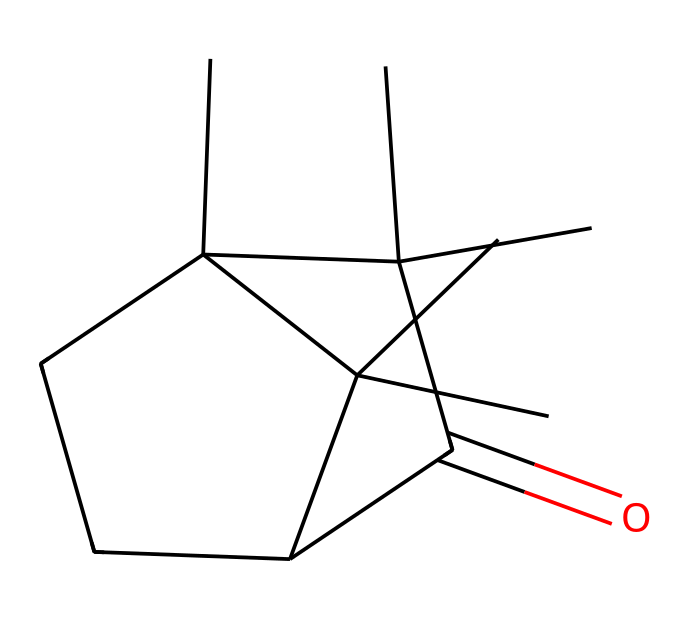How many carbon atoms are present in camphor? Counting the carbon atoms indicated in the structure, there are 10 carbon atoms in total.
Answer: 10 What is the functional group in camphor? The chemical structure contains a carbonyl group (C=O) which is characteristic of ketones.
Answer: carbonyl How many hydrogen atoms are in camphor? By analyzing the structure and following the valency rules, there are 16 hydrogen atoms.
Answer: 16 What makes camphor classified as a ketone? Camphor contains a carbonyl group (>C=O) bonded to two carbon atoms, fulfilling the definition of a ketone.
Answer: carbonyl group What is the molecular formula of camphor? To derive the molecular formula, we combine the counts of each type of atom: C10H16O.
Answer: C10H16O How many rings are present in the camphor structure? The structure shows 2 cyclic components, hence there are two rings in camphor.
Answer: 2 Which type of isomerism is present in camphor? Camphor exhibits configurational isomerism due to the presence of restricted rotation around its double bond in the carbonyl group.
Answer: configurational isomerism 